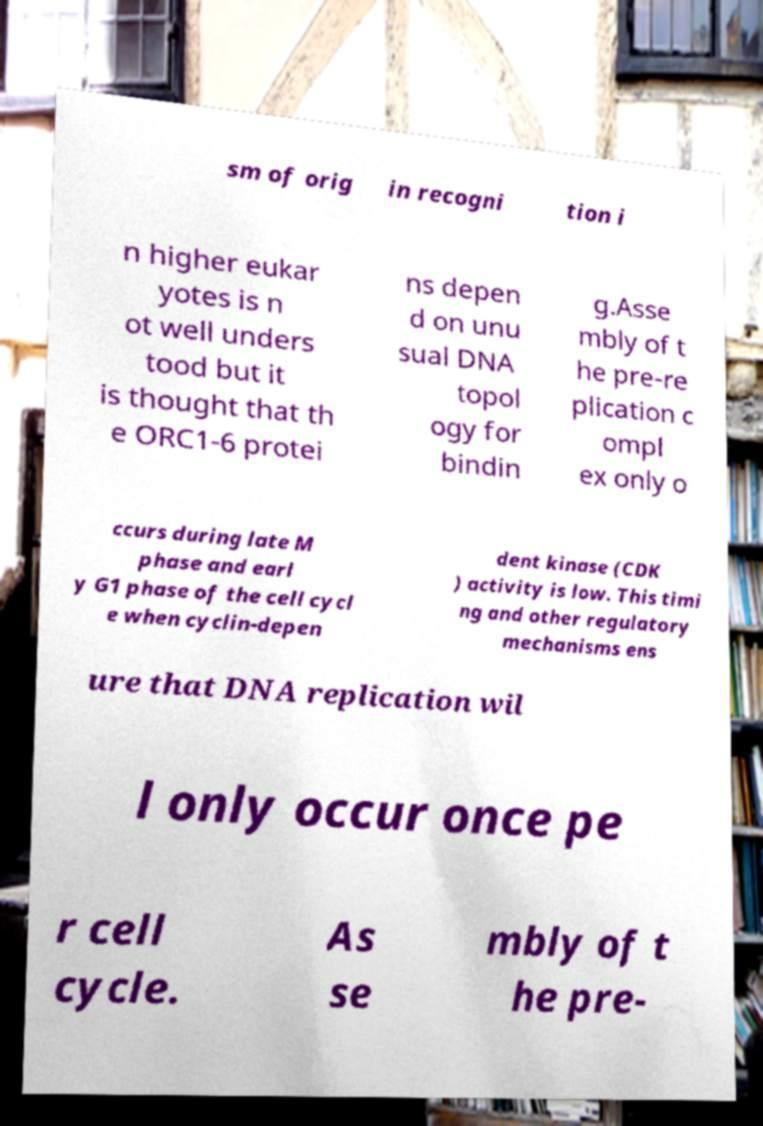Can you accurately transcribe the text from the provided image for me? sm of orig in recogni tion i n higher eukar yotes is n ot well unders tood but it is thought that th e ORC1-6 protei ns depen d on unu sual DNA topol ogy for bindin g.Asse mbly of t he pre-re plication c ompl ex only o ccurs during late M phase and earl y G1 phase of the cell cycl e when cyclin-depen dent kinase (CDK ) activity is low. This timi ng and other regulatory mechanisms ens ure that DNA replication wil l only occur once pe r cell cycle. As se mbly of t he pre- 